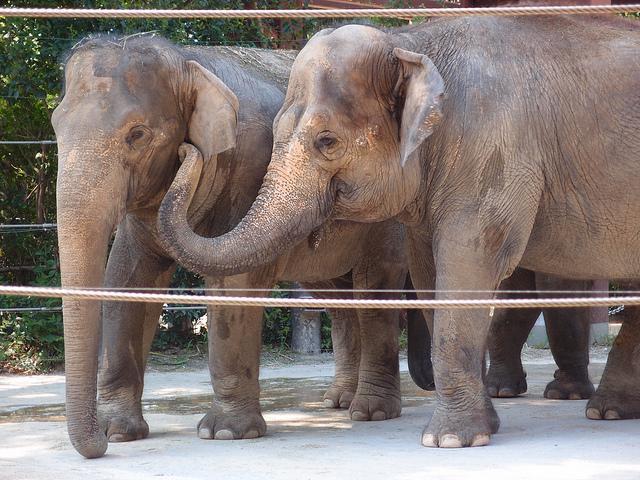How many elephants are there?
Give a very brief answer. 2. How many elephants can be seen?
Give a very brief answer. 3. How many purple suitcases are in the image?
Give a very brief answer. 0. 